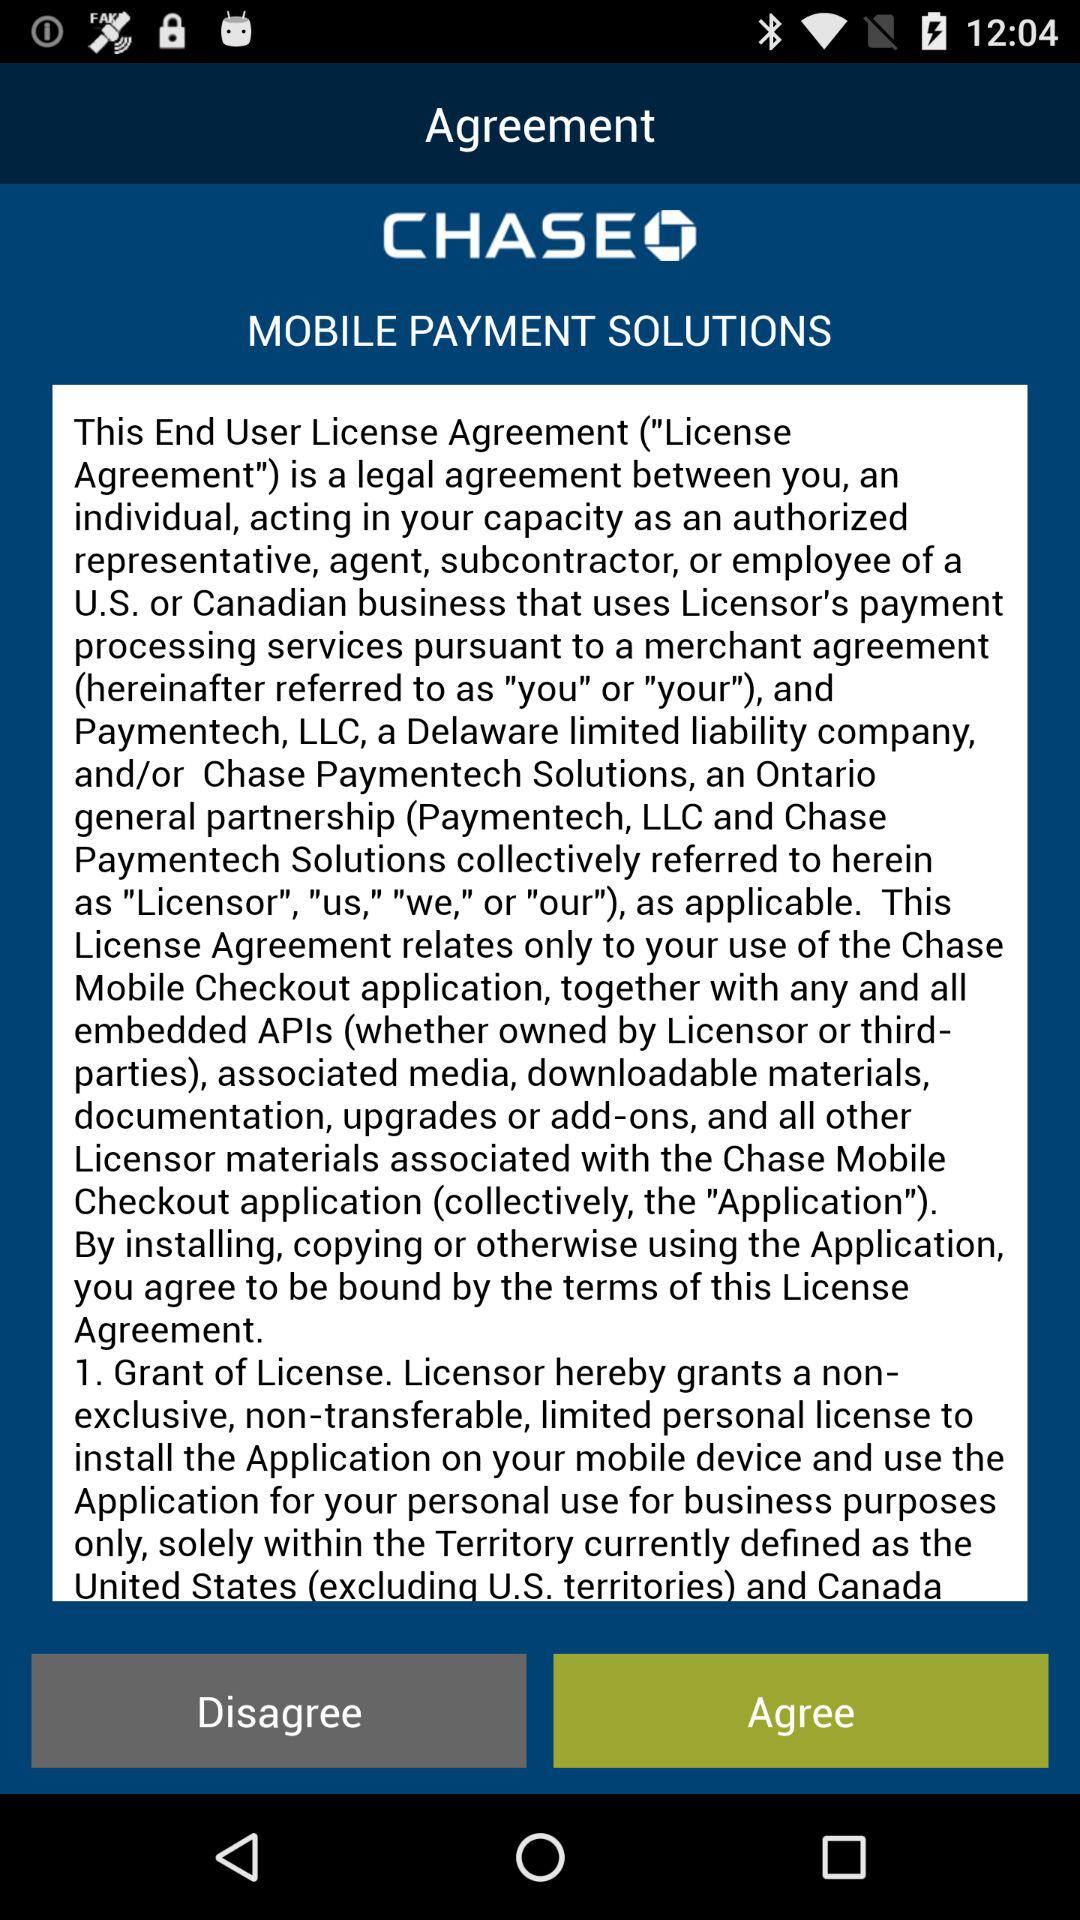What is the application name? The application name is "CHASE". 